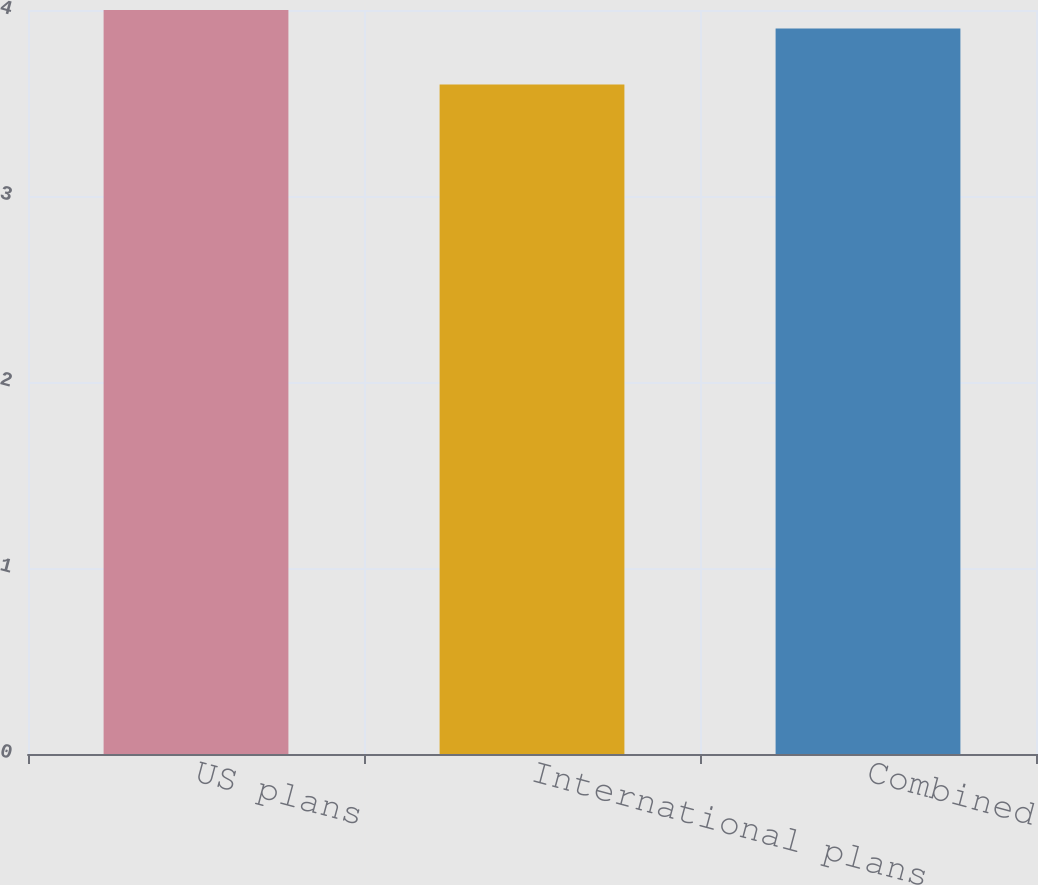Convert chart. <chart><loc_0><loc_0><loc_500><loc_500><bar_chart><fcel>US plans<fcel>International plans<fcel>Combined<nl><fcel>4<fcel>3.6<fcel>3.9<nl></chart> 